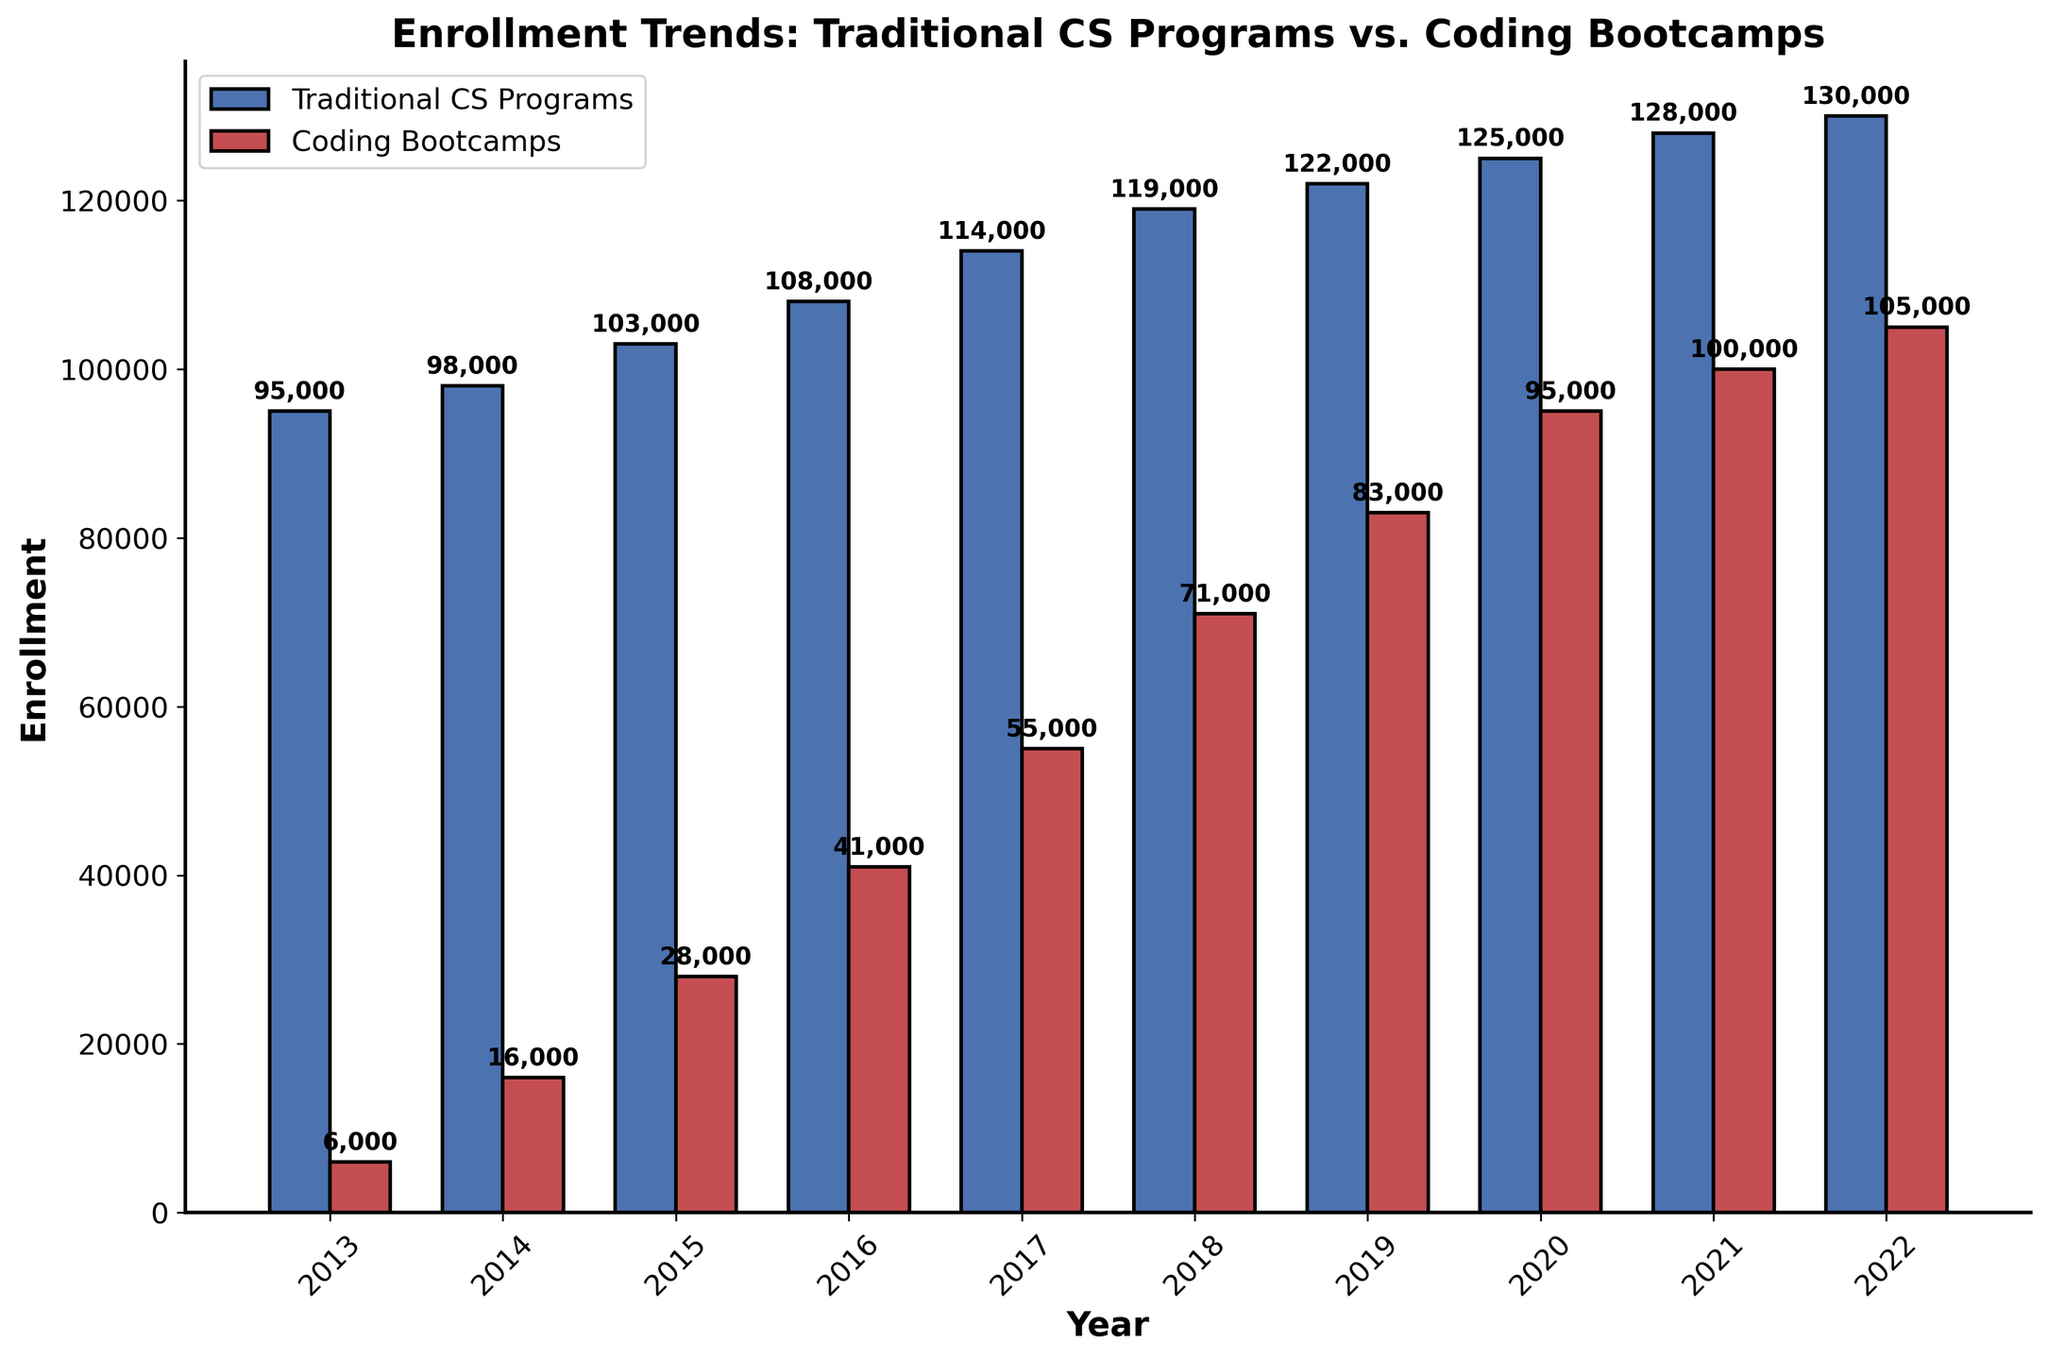Which year had the highest enrollment in coding bootcamps? By looking at the height of the red bars representing coding bootcamp enrollments, the year with the highest bar is 2022.
Answer: 2022 What was the difference in enrollment between traditional CS programs and coding bootcamps in 2013? The enrollment for traditional CS programs in 2013 was 95,000 and for coding bootcamps, it was 6,000. The difference is 95,000 - 6,000 = 89,000.
Answer: 89,000 How did the enrollment in traditional CS programs change from 2013 to 2022? The enrollment in traditional CS programs in 2013 was 95,000 and in 2022 it was 130,000. The change is 130,000 - 95,000 = 35,000.
Answer: Increased by 35,000 Which program saw a greater increase in enrollment from 2016 to 2020, traditional CS programs or coding bootcamps? In 2016, traditional CS programs had 108,000 enrollments and in 2020 had 125,000, an increase of 17,000. Coding bootcamps had 41,000 enrollments in 2016 and 95,000 in 2020, an increase of 54,000. Thus, coding bootcamps saw a greater increase.
Answer: Coding bootcamps What is the average enrollment in coding bootcamps from 2015 to 2019? The enrollments for coding bootcamps from 2015 to 2019 are 28,000, 41,000, 55,000, 71,000, and 83,000. The sum is 28,000 + 41,000 + 55,000 + 71,000 + 83,000 = 278,000. The average is 278,000 / 5 = 55,600.
Answer: 55,600 In which year did coding bootcamp enrollment first exceed 50,000? By looking at the height of the red bars, coding bootcamp enrollment first exceeded 50,000 in 2017.
Answer: 2017 Compare the growth rate in enrollments for traditional CS programs and coding bootcamps from 2013 to 2022. Traditional CS programs increased from 95,000 in 2013 to 130,000 in 2022, a growth rate of (130,000 - 95,000) / 95,000 = 0.368 or 36.8%. Coding bootcamps grew from 6,000 in 2013 to 105,000 in 2022, a growth rate of (105,000 - 6,000) / 6,000 = 16.5 or 1,650%.
Answer: Coding bootcamps had a higher growth rate How many years did it take for coding bootcamp enrollment to surpass 100,000? Enrollment in coding bootcamps surpassed 100,000 in 2021. Since coding bootcamps started in 2013, it took 2021 - 2013 = 8 years.
Answer: 8 years By how much did the enrollment in coding bootcamps increase from 2017 to 2022? The enrollment for coding bootcamps in 2017 was 55,000 and in 2022 was 105,000. The increase is 105,000 - 55,000 = 50,000.
Answer: 50,000 